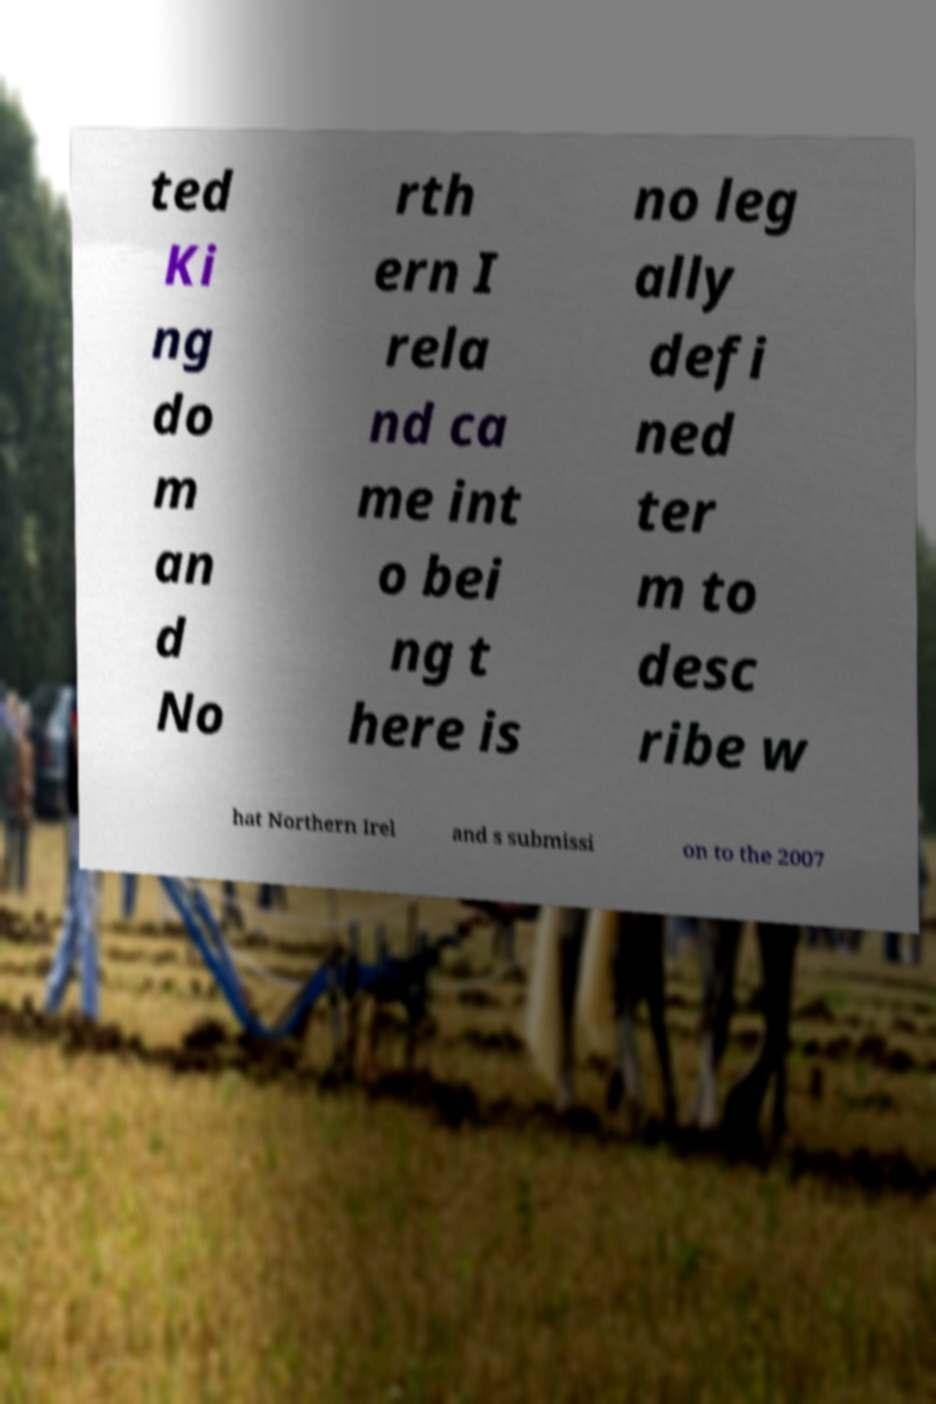Please identify and transcribe the text found in this image. ted Ki ng do m an d No rth ern I rela nd ca me int o bei ng t here is no leg ally defi ned ter m to desc ribe w hat Northern Irel and s submissi on to the 2007 